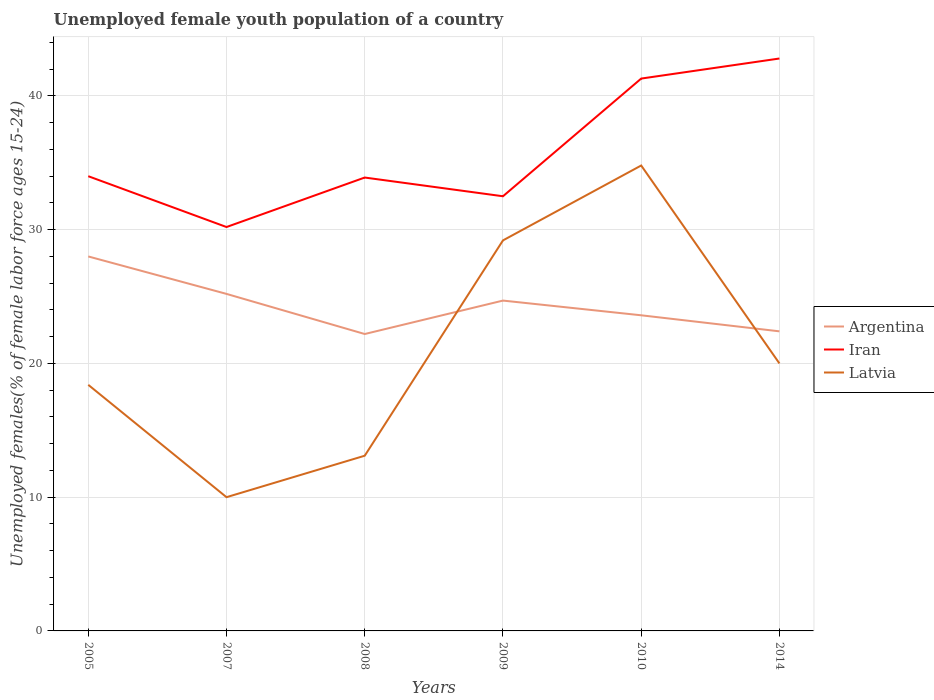How many different coloured lines are there?
Provide a succinct answer. 3. Is the number of lines equal to the number of legend labels?
Your answer should be very brief. Yes. Across all years, what is the maximum percentage of unemployed female youth population in Argentina?
Give a very brief answer. 22.2. In which year was the percentage of unemployed female youth population in Latvia maximum?
Make the answer very short. 2007. What is the difference between the highest and the second highest percentage of unemployed female youth population in Latvia?
Ensure brevity in your answer.  24.8. Is the percentage of unemployed female youth population in Argentina strictly greater than the percentage of unemployed female youth population in Latvia over the years?
Provide a succinct answer. No. How many lines are there?
Give a very brief answer. 3. What is the difference between two consecutive major ticks on the Y-axis?
Give a very brief answer. 10. Are the values on the major ticks of Y-axis written in scientific E-notation?
Provide a short and direct response. No. Does the graph contain any zero values?
Provide a succinct answer. No. Does the graph contain grids?
Provide a succinct answer. Yes. How are the legend labels stacked?
Your answer should be very brief. Vertical. What is the title of the graph?
Offer a very short reply. Unemployed female youth population of a country. Does "Arab World" appear as one of the legend labels in the graph?
Your answer should be compact. No. What is the label or title of the X-axis?
Provide a succinct answer. Years. What is the label or title of the Y-axis?
Your answer should be very brief. Unemployed females(% of female labor force ages 15-24). What is the Unemployed females(% of female labor force ages 15-24) in Argentina in 2005?
Provide a succinct answer. 28. What is the Unemployed females(% of female labor force ages 15-24) in Latvia in 2005?
Give a very brief answer. 18.4. What is the Unemployed females(% of female labor force ages 15-24) in Argentina in 2007?
Provide a succinct answer. 25.2. What is the Unemployed females(% of female labor force ages 15-24) of Iran in 2007?
Your response must be concise. 30.2. What is the Unemployed females(% of female labor force ages 15-24) of Argentina in 2008?
Provide a short and direct response. 22.2. What is the Unemployed females(% of female labor force ages 15-24) in Iran in 2008?
Provide a short and direct response. 33.9. What is the Unemployed females(% of female labor force ages 15-24) in Latvia in 2008?
Keep it short and to the point. 13.1. What is the Unemployed females(% of female labor force ages 15-24) in Argentina in 2009?
Provide a succinct answer. 24.7. What is the Unemployed females(% of female labor force ages 15-24) of Iran in 2009?
Provide a succinct answer. 32.5. What is the Unemployed females(% of female labor force ages 15-24) in Latvia in 2009?
Offer a very short reply. 29.2. What is the Unemployed females(% of female labor force ages 15-24) of Argentina in 2010?
Provide a succinct answer. 23.6. What is the Unemployed females(% of female labor force ages 15-24) in Iran in 2010?
Your answer should be compact. 41.3. What is the Unemployed females(% of female labor force ages 15-24) in Latvia in 2010?
Your answer should be very brief. 34.8. What is the Unemployed females(% of female labor force ages 15-24) of Argentina in 2014?
Keep it short and to the point. 22.4. What is the Unemployed females(% of female labor force ages 15-24) of Iran in 2014?
Provide a succinct answer. 42.8. What is the Unemployed females(% of female labor force ages 15-24) in Latvia in 2014?
Offer a terse response. 20. Across all years, what is the maximum Unemployed females(% of female labor force ages 15-24) of Iran?
Ensure brevity in your answer.  42.8. Across all years, what is the maximum Unemployed females(% of female labor force ages 15-24) in Latvia?
Your response must be concise. 34.8. Across all years, what is the minimum Unemployed females(% of female labor force ages 15-24) of Argentina?
Ensure brevity in your answer.  22.2. Across all years, what is the minimum Unemployed females(% of female labor force ages 15-24) of Iran?
Make the answer very short. 30.2. What is the total Unemployed females(% of female labor force ages 15-24) in Argentina in the graph?
Ensure brevity in your answer.  146.1. What is the total Unemployed females(% of female labor force ages 15-24) in Iran in the graph?
Make the answer very short. 214.7. What is the total Unemployed females(% of female labor force ages 15-24) in Latvia in the graph?
Give a very brief answer. 125.5. What is the difference between the Unemployed females(% of female labor force ages 15-24) in Argentina in 2005 and that in 2007?
Provide a succinct answer. 2.8. What is the difference between the Unemployed females(% of female labor force ages 15-24) in Latvia in 2005 and that in 2007?
Offer a terse response. 8.4. What is the difference between the Unemployed females(% of female labor force ages 15-24) of Argentina in 2005 and that in 2008?
Make the answer very short. 5.8. What is the difference between the Unemployed females(% of female labor force ages 15-24) in Iran in 2005 and that in 2008?
Offer a terse response. 0.1. What is the difference between the Unemployed females(% of female labor force ages 15-24) in Argentina in 2005 and that in 2009?
Provide a short and direct response. 3.3. What is the difference between the Unemployed females(% of female labor force ages 15-24) in Iran in 2005 and that in 2010?
Ensure brevity in your answer.  -7.3. What is the difference between the Unemployed females(% of female labor force ages 15-24) of Latvia in 2005 and that in 2010?
Your response must be concise. -16.4. What is the difference between the Unemployed females(% of female labor force ages 15-24) in Argentina in 2005 and that in 2014?
Your answer should be compact. 5.6. What is the difference between the Unemployed females(% of female labor force ages 15-24) of Iran in 2005 and that in 2014?
Provide a succinct answer. -8.8. What is the difference between the Unemployed females(% of female labor force ages 15-24) of Latvia in 2005 and that in 2014?
Keep it short and to the point. -1.6. What is the difference between the Unemployed females(% of female labor force ages 15-24) of Argentina in 2007 and that in 2008?
Offer a very short reply. 3. What is the difference between the Unemployed females(% of female labor force ages 15-24) in Iran in 2007 and that in 2008?
Make the answer very short. -3.7. What is the difference between the Unemployed females(% of female labor force ages 15-24) in Latvia in 2007 and that in 2008?
Give a very brief answer. -3.1. What is the difference between the Unemployed females(% of female labor force ages 15-24) of Argentina in 2007 and that in 2009?
Offer a very short reply. 0.5. What is the difference between the Unemployed females(% of female labor force ages 15-24) of Latvia in 2007 and that in 2009?
Give a very brief answer. -19.2. What is the difference between the Unemployed females(% of female labor force ages 15-24) in Latvia in 2007 and that in 2010?
Make the answer very short. -24.8. What is the difference between the Unemployed females(% of female labor force ages 15-24) in Iran in 2007 and that in 2014?
Your response must be concise. -12.6. What is the difference between the Unemployed females(% of female labor force ages 15-24) in Argentina in 2008 and that in 2009?
Offer a terse response. -2.5. What is the difference between the Unemployed females(% of female labor force ages 15-24) of Iran in 2008 and that in 2009?
Offer a very short reply. 1.4. What is the difference between the Unemployed females(% of female labor force ages 15-24) in Latvia in 2008 and that in 2009?
Give a very brief answer. -16.1. What is the difference between the Unemployed females(% of female labor force ages 15-24) in Latvia in 2008 and that in 2010?
Keep it short and to the point. -21.7. What is the difference between the Unemployed females(% of female labor force ages 15-24) of Argentina in 2008 and that in 2014?
Provide a short and direct response. -0.2. What is the difference between the Unemployed females(% of female labor force ages 15-24) of Iran in 2008 and that in 2014?
Make the answer very short. -8.9. What is the difference between the Unemployed females(% of female labor force ages 15-24) in Latvia in 2008 and that in 2014?
Provide a succinct answer. -6.9. What is the difference between the Unemployed females(% of female labor force ages 15-24) of Latvia in 2009 and that in 2010?
Provide a short and direct response. -5.6. What is the difference between the Unemployed females(% of female labor force ages 15-24) in Argentina in 2010 and that in 2014?
Offer a terse response. 1.2. What is the difference between the Unemployed females(% of female labor force ages 15-24) in Iran in 2010 and that in 2014?
Ensure brevity in your answer.  -1.5. What is the difference between the Unemployed females(% of female labor force ages 15-24) in Latvia in 2010 and that in 2014?
Ensure brevity in your answer.  14.8. What is the difference between the Unemployed females(% of female labor force ages 15-24) of Argentina in 2005 and the Unemployed females(% of female labor force ages 15-24) of Iran in 2007?
Keep it short and to the point. -2.2. What is the difference between the Unemployed females(% of female labor force ages 15-24) of Argentina in 2005 and the Unemployed females(% of female labor force ages 15-24) of Latvia in 2008?
Offer a terse response. 14.9. What is the difference between the Unemployed females(% of female labor force ages 15-24) in Iran in 2005 and the Unemployed females(% of female labor force ages 15-24) in Latvia in 2008?
Provide a succinct answer. 20.9. What is the difference between the Unemployed females(% of female labor force ages 15-24) of Argentina in 2005 and the Unemployed females(% of female labor force ages 15-24) of Iran in 2009?
Provide a short and direct response. -4.5. What is the difference between the Unemployed females(% of female labor force ages 15-24) of Iran in 2005 and the Unemployed females(% of female labor force ages 15-24) of Latvia in 2009?
Give a very brief answer. 4.8. What is the difference between the Unemployed females(% of female labor force ages 15-24) in Argentina in 2005 and the Unemployed females(% of female labor force ages 15-24) in Iran in 2010?
Your answer should be compact. -13.3. What is the difference between the Unemployed females(% of female labor force ages 15-24) in Argentina in 2005 and the Unemployed females(% of female labor force ages 15-24) in Iran in 2014?
Your answer should be very brief. -14.8. What is the difference between the Unemployed females(% of female labor force ages 15-24) in Argentina in 2007 and the Unemployed females(% of female labor force ages 15-24) in Latvia in 2008?
Your answer should be very brief. 12.1. What is the difference between the Unemployed females(% of female labor force ages 15-24) in Argentina in 2007 and the Unemployed females(% of female labor force ages 15-24) in Iran in 2009?
Ensure brevity in your answer.  -7.3. What is the difference between the Unemployed females(% of female labor force ages 15-24) in Argentina in 2007 and the Unemployed females(% of female labor force ages 15-24) in Latvia in 2009?
Keep it short and to the point. -4. What is the difference between the Unemployed females(% of female labor force ages 15-24) in Iran in 2007 and the Unemployed females(% of female labor force ages 15-24) in Latvia in 2009?
Your answer should be very brief. 1. What is the difference between the Unemployed females(% of female labor force ages 15-24) in Argentina in 2007 and the Unemployed females(% of female labor force ages 15-24) in Iran in 2010?
Provide a succinct answer. -16.1. What is the difference between the Unemployed females(% of female labor force ages 15-24) of Argentina in 2007 and the Unemployed females(% of female labor force ages 15-24) of Latvia in 2010?
Ensure brevity in your answer.  -9.6. What is the difference between the Unemployed females(% of female labor force ages 15-24) of Argentina in 2007 and the Unemployed females(% of female labor force ages 15-24) of Iran in 2014?
Your answer should be compact. -17.6. What is the difference between the Unemployed females(% of female labor force ages 15-24) of Argentina in 2007 and the Unemployed females(% of female labor force ages 15-24) of Latvia in 2014?
Keep it short and to the point. 5.2. What is the difference between the Unemployed females(% of female labor force ages 15-24) in Argentina in 2008 and the Unemployed females(% of female labor force ages 15-24) in Latvia in 2009?
Provide a succinct answer. -7. What is the difference between the Unemployed females(% of female labor force ages 15-24) of Iran in 2008 and the Unemployed females(% of female labor force ages 15-24) of Latvia in 2009?
Offer a terse response. 4.7. What is the difference between the Unemployed females(% of female labor force ages 15-24) of Argentina in 2008 and the Unemployed females(% of female labor force ages 15-24) of Iran in 2010?
Make the answer very short. -19.1. What is the difference between the Unemployed females(% of female labor force ages 15-24) in Argentina in 2008 and the Unemployed females(% of female labor force ages 15-24) in Latvia in 2010?
Offer a very short reply. -12.6. What is the difference between the Unemployed females(% of female labor force ages 15-24) of Argentina in 2008 and the Unemployed females(% of female labor force ages 15-24) of Iran in 2014?
Offer a terse response. -20.6. What is the difference between the Unemployed females(% of female labor force ages 15-24) of Iran in 2008 and the Unemployed females(% of female labor force ages 15-24) of Latvia in 2014?
Your answer should be compact. 13.9. What is the difference between the Unemployed females(% of female labor force ages 15-24) of Argentina in 2009 and the Unemployed females(% of female labor force ages 15-24) of Iran in 2010?
Provide a succinct answer. -16.6. What is the difference between the Unemployed females(% of female labor force ages 15-24) in Argentina in 2009 and the Unemployed females(% of female labor force ages 15-24) in Latvia in 2010?
Give a very brief answer. -10.1. What is the difference between the Unemployed females(% of female labor force ages 15-24) in Iran in 2009 and the Unemployed females(% of female labor force ages 15-24) in Latvia in 2010?
Provide a short and direct response. -2.3. What is the difference between the Unemployed females(% of female labor force ages 15-24) in Argentina in 2009 and the Unemployed females(% of female labor force ages 15-24) in Iran in 2014?
Give a very brief answer. -18.1. What is the difference between the Unemployed females(% of female labor force ages 15-24) of Argentina in 2010 and the Unemployed females(% of female labor force ages 15-24) of Iran in 2014?
Offer a terse response. -19.2. What is the difference between the Unemployed females(% of female labor force ages 15-24) in Argentina in 2010 and the Unemployed females(% of female labor force ages 15-24) in Latvia in 2014?
Provide a short and direct response. 3.6. What is the difference between the Unemployed females(% of female labor force ages 15-24) of Iran in 2010 and the Unemployed females(% of female labor force ages 15-24) of Latvia in 2014?
Ensure brevity in your answer.  21.3. What is the average Unemployed females(% of female labor force ages 15-24) of Argentina per year?
Offer a terse response. 24.35. What is the average Unemployed females(% of female labor force ages 15-24) in Iran per year?
Keep it short and to the point. 35.78. What is the average Unemployed females(% of female labor force ages 15-24) in Latvia per year?
Ensure brevity in your answer.  20.92. In the year 2005, what is the difference between the Unemployed females(% of female labor force ages 15-24) of Argentina and Unemployed females(% of female labor force ages 15-24) of Iran?
Make the answer very short. -6. In the year 2007, what is the difference between the Unemployed females(% of female labor force ages 15-24) of Argentina and Unemployed females(% of female labor force ages 15-24) of Iran?
Offer a terse response. -5. In the year 2007, what is the difference between the Unemployed females(% of female labor force ages 15-24) of Iran and Unemployed females(% of female labor force ages 15-24) of Latvia?
Your answer should be very brief. 20.2. In the year 2008, what is the difference between the Unemployed females(% of female labor force ages 15-24) in Argentina and Unemployed females(% of female labor force ages 15-24) in Iran?
Make the answer very short. -11.7. In the year 2008, what is the difference between the Unemployed females(% of female labor force ages 15-24) of Argentina and Unemployed females(% of female labor force ages 15-24) of Latvia?
Your answer should be very brief. 9.1. In the year 2008, what is the difference between the Unemployed females(% of female labor force ages 15-24) of Iran and Unemployed females(% of female labor force ages 15-24) of Latvia?
Offer a terse response. 20.8. In the year 2009, what is the difference between the Unemployed females(% of female labor force ages 15-24) of Argentina and Unemployed females(% of female labor force ages 15-24) of Latvia?
Offer a terse response. -4.5. In the year 2010, what is the difference between the Unemployed females(% of female labor force ages 15-24) in Argentina and Unemployed females(% of female labor force ages 15-24) in Iran?
Ensure brevity in your answer.  -17.7. In the year 2010, what is the difference between the Unemployed females(% of female labor force ages 15-24) of Iran and Unemployed females(% of female labor force ages 15-24) of Latvia?
Keep it short and to the point. 6.5. In the year 2014, what is the difference between the Unemployed females(% of female labor force ages 15-24) in Argentina and Unemployed females(% of female labor force ages 15-24) in Iran?
Offer a terse response. -20.4. In the year 2014, what is the difference between the Unemployed females(% of female labor force ages 15-24) in Iran and Unemployed females(% of female labor force ages 15-24) in Latvia?
Your answer should be compact. 22.8. What is the ratio of the Unemployed females(% of female labor force ages 15-24) in Argentina in 2005 to that in 2007?
Your response must be concise. 1.11. What is the ratio of the Unemployed females(% of female labor force ages 15-24) of Iran in 2005 to that in 2007?
Offer a terse response. 1.13. What is the ratio of the Unemployed females(% of female labor force ages 15-24) in Latvia in 2005 to that in 2007?
Keep it short and to the point. 1.84. What is the ratio of the Unemployed females(% of female labor force ages 15-24) in Argentina in 2005 to that in 2008?
Your answer should be compact. 1.26. What is the ratio of the Unemployed females(% of female labor force ages 15-24) in Latvia in 2005 to that in 2008?
Your response must be concise. 1.4. What is the ratio of the Unemployed females(% of female labor force ages 15-24) of Argentina in 2005 to that in 2009?
Offer a very short reply. 1.13. What is the ratio of the Unemployed females(% of female labor force ages 15-24) in Iran in 2005 to that in 2009?
Your answer should be very brief. 1.05. What is the ratio of the Unemployed females(% of female labor force ages 15-24) of Latvia in 2005 to that in 2009?
Ensure brevity in your answer.  0.63. What is the ratio of the Unemployed females(% of female labor force ages 15-24) in Argentina in 2005 to that in 2010?
Keep it short and to the point. 1.19. What is the ratio of the Unemployed females(% of female labor force ages 15-24) in Iran in 2005 to that in 2010?
Your answer should be compact. 0.82. What is the ratio of the Unemployed females(% of female labor force ages 15-24) in Latvia in 2005 to that in 2010?
Ensure brevity in your answer.  0.53. What is the ratio of the Unemployed females(% of female labor force ages 15-24) of Iran in 2005 to that in 2014?
Ensure brevity in your answer.  0.79. What is the ratio of the Unemployed females(% of female labor force ages 15-24) in Argentina in 2007 to that in 2008?
Your answer should be compact. 1.14. What is the ratio of the Unemployed females(% of female labor force ages 15-24) in Iran in 2007 to that in 2008?
Make the answer very short. 0.89. What is the ratio of the Unemployed females(% of female labor force ages 15-24) in Latvia in 2007 to that in 2008?
Make the answer very short. 0.76. What is the ratio of the Unemployed females(% of female labor force ages 15-24) of Argentina in 2007 to that in 2009?
Make the answer very short. 1.02. What is the ratio of the Unemployed females(% of female labor force ages 15-24) in Iran in 2007 to that in 2009?
Provide a short and direct response. 0.93. What is the ratio of the Unemployed females(% of female labor force ages 15-24) in Latvia in 2007 to that in 2009?
Provide a short and direct response. 0.34. What is the ratio of the Unemployed females(% of female labor force ages 15-24) in Argentina in 2007 to that in 2010?
Ensure brevity in your answer.  1.07. What is the ratio of the Unemployed females(% of female labor force ages 15-24) in Iran in 2007 to that in 2010?
Your answer should be compact. 0.73. What is the ratio of the Unemployed females(% of female labor force ages 15-24) of Latvia in 2007 to that in 2010?
Your response must be concise. 0.29. What is the ratio of the Unemployed females(% of female labor force ages 15-24) of Argentina in 2007 to that in 2014?
Make the answer very short. 1.12. What is the ratio of the Unemployed females(% of female labor force ages 15-24) of Iran in 2007 to that in 2014?
Offer a terse response. 0.71. What is the ratio of the Unemployed females(% of female labor force ages 15-24) in Latvia in 2007 to that in 2014?
Provide a succinct answer. 0.5. What is the ratio of the Unemployed females(% of female labor force ages 15-24) of Argentina in 2008 to that in 2009?
Provide a succinct answer. 0.9. What is the ratio of the Unemployed females(% of female labor force ages 15-24) in Iran in 2008 to that in 2009?
Offer a terse response. 1.04. What is the ratio of the Unemployed females(% of female labor force ages 15-24) of Latvia in 2008 to that in 2009?
Offer a terse response. 0.45. What is the ratio of the Unemployed females(% of female labor force ages 15-24) of Argentina in 2008 to that in 2010?
Your answer should be compact. 0.94. What is the ratio of the Unemployed females(% of female labor force ages 15-24) in Iran in 2008 to that in 2010?
Your answer should be compact. 0.82. What is the ratio of the Unemployed females(% of female labor force ages 15-24) of Latvia in 2008 to that in 2010?
Ensure brevity in your answer.  0.38. What is the ratio of the Unemployed females(% of female labor force ages 15-24) in Iran in 2008 to that in 2014?
Offer a very short reply. 0.79. What is the ratio of the Unemployed females(% of female labor force ages 15-24) in Latvia in 2008 to that in 2014?
Provide a succinct answer. 0.66. What is the ratio of the Unemployed females(% of female labor force ages 15-24) in Argentina in 2009 to that in 2010?
Ensure brevity in your answer.  1.05. What is the ratio of the Unemployed females(% of female labor force ages 15-24) of Iran in 2009 to that in 2010?
Offer a very short reply. 0.79. What is the ratio of the Unemployed females(% of female labor force ages 15-24) of Latvia in 2009 to that in 2010?
Your response must be concise. 0.84. What is the ratio of the Unemployed females(% of female labor force ages 15-24) of Argentina in 2009 to that in 2014?
Ensure brevity in your answer.  1.1. What is the ratio of the Unemployed females(% of female labor force ages 15-24) of Iran in 2009 to that in 2014?
Your response must be concise. 0.76. What is the ratio of the Unemployed females(% of female labor force ages 15-24) in Latvia in 2009 to that in 2014?
Offer a very short reply. 1.46. What is the ratio of the Unemployed females(% of female labor force ages 15-24) in Argentina in 2010 to that in 2014?
Give a very brief answer. 1.05. What is the ratio of the Unemployed females(% of female labor force ages 15-24) of Iran in 2010 to that in 2014?
Provide a succinct answer. 0.96. What is the ratio of the Unemployed females(% of female labor force ages 15-24) in Latvia in 2010 to that in 2014?
Provide a succinct answer. 1.74. What is the difference between the highest and the second highest Unemployed females(% of female labor force ages 15-24) of Iran?
Ensure brevity in your answer.  1.5. What is the difference between the highest and the lowest Unemployed females(% of female labor force ages 15-24) in Argentina?
Your response must be concise. 5.8. What is the difference between the highest and the lowest Unemployed females(% of female labor force ages 15-24) in Iran?
Offer a terse response. 12.6. What is the difference between the highest and the lowest Unemployed females(% of female labor force ages 15-24) in Latvia?
Provide a short and direct response. 24.8. 